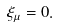<formula> <loc_0><loc_0><loc_500><loc_500>\xi _ { \mu } = 0 .</formula> 